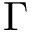Convert formula to latex. <formula><loc_0><loc_0><loc_500><loc_500>\Gamma</formula> 